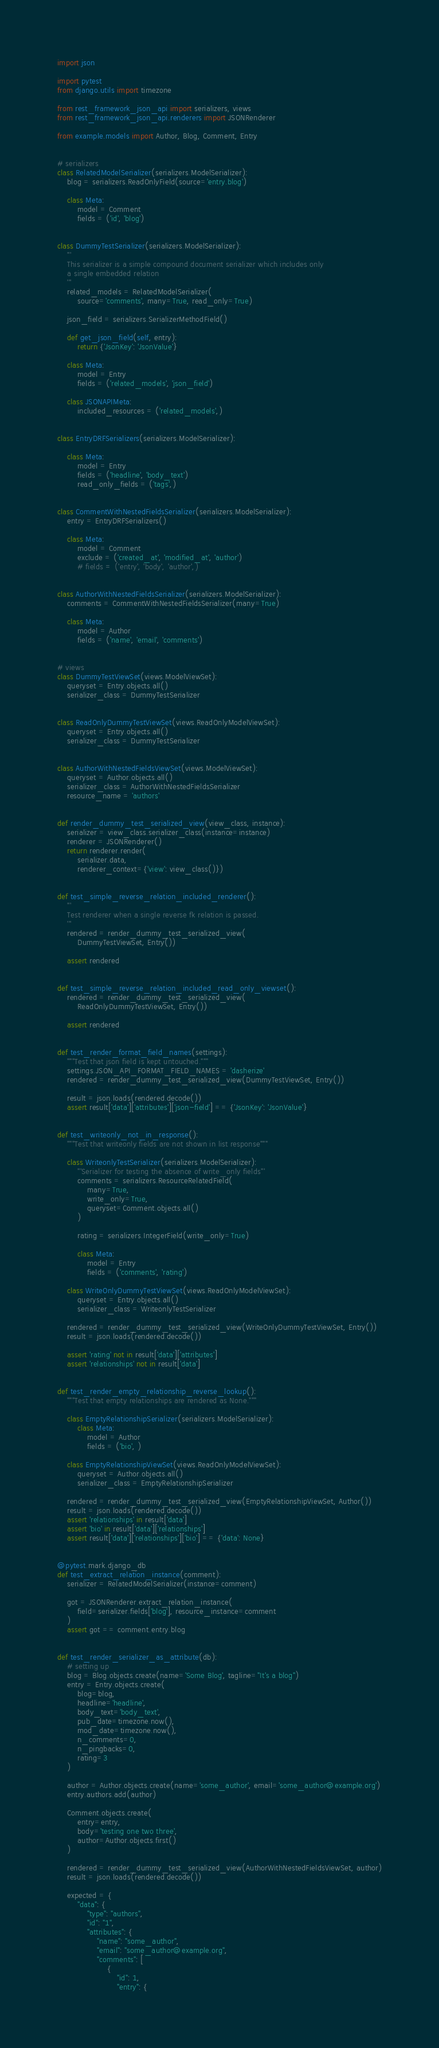<code> <loc_0><loc_0><loc_500><loc_500><_Python_>import json

import pytest
from django.utils import timezone

from rest_framework_json_api import serializers, views
from rest_framework_json_api.renderers import JSONRenderer

from example.models import Author, Blog, Comment, Entry


# serializers
class RelatedModelSerializer(serializers.ModelSerializer):
    blog = serializers.ReadOnlyField(source='entry.blog')

    class Meta:
        model = Comment
        fields = ('id', 'blog')


class DummyTestSerializer(serializers.ModelSerializer):
    '''
    This serializer is a simple compound document serializer which includes only
    a single embedded relation
    '''
    related_models = RelatedModelSerializer(
        source='comments', many=True, read_only=True)

    json_field = serializers.SerializerMethodField()

    def get_json_field(self, entry):
        return {'JsonKey': 'JsonValue'}

    class Meta:
        model = Entry
        fields = ('related_models', 'json_field')

    class JSONAPIMeta:
        included_resources = ('related_models',)


class EntryDRFSerializers(serializers.ModelSerializer):

    class Meta:
        model = Entry
        fields = ('headline', 'body_text')
        read_only_fields = ('tags',)


class CommentWithNestedFieldsSerializer(serializers.ModelSerializer):
    entry = EntryDRFSerializers()

    class Meta:
        model = Comment
        exclude = ('created_at', 'modified_at', 'author')
        # fields = ('entry', 'body', 'author',)


class AuthorWithNestedFieldsSerializer(serializers.ModelSerializer):
    comments = CommentWithNestedFieldsSerializer(many=True)

    class Meta:
        model = Author
        fields = ('name', 'email', 'comments')


# views
class DummyTestViewSet(views.ModelViewSet):
    queryset = Entry.objects.all()
    serializer_class = DummyTestSerializer


class ReadOnlyDummyTestViewSet(views.ReadOnlyModelViewSet):
    queryset = Entry.objects.all()
    serializer_class = DummyTestSerializer


class AuthorWithNestedFieldsViewSet(views.ModelViewSet):
    queryset = Author.objects.all()
    serializer_class = AuthorWithNestedFieldsSerializer
    resource_name = 'authors'


def render_dummy_test_serialized_view(view_class, instance):
    serializer = view_class.serializer_class(instance=instance)
    renderer = JSONRenderer()
    return renderer.render(
        serializer.data,
        renderer_context={'view': view_class()})


def test_simple_reverse_relation_included_renderer():
    '''
    Test renderer when a single reverse fk relation is passed.
    '''
    rendered = render_dummy_test_serialized_view(
        DummyTestViewSet, Entry())

    assert rendered


def test_simple_reverse_relation_included_read_only_viewset():
    rendered = render_dummy_test_serialized_view(
        ReadOnlyDummyTestViewSet, Entry())

    assert rendered


def test_render_format_field_names(settings):
    """Test that json field is kept untouched."""
    settings.JSON_API_FORMAT_FIELD_NAMES = 'dasherize'
    rendered = render_dummy_test_serialized_view(DummyTestViewSet, Entry())

    result = json.loads(rendered.decode())
    assert result['data']['attributes']['json-field'] == {'JsonKey': 'JsonValue'}


def test_writeonly_not_in_response():
    """Test that writeonly fields are not shown in list response"""

    class WriteonlyTestSerializer(serializers.ModelSerializer):
        '''Serializer for testing the absence of write_only fields'''
        comments = serializers.ResourceRelatedField(
            many=True,
            write_only=True,
            queryset=Comment.objects.all()
        )

        rating = serializers.IntegerField(write_only=True)

        class Meta:
            model = Entry
            fields = ('comments', 'rating')

    class WriteOnlyDummyTestViewSet(views.ReadOnlyModelViewSet):
        queryset = Entry.objects.all()
        serializer_class = WriteonlyTestSerializer

    rendered = render_dummy_test_serialized_view(WriteOnlyDummyTestViewSet, Entry())
    result = json.loads(rendered.decode())

    assert 'rating' not in result['data']['attributes']
    assert 'relationships' not in result['data']


def test_render_empty_relationship_reverse_lookup():
    """Test that empty relationships are rendered as None."""

    class EmptyRelationshipSerializer(serializers.ModelSerializer):
        class Meta:
            model = Author
            fields = ('bio', )

    class EmptyRelationshipViewSet(views.ReadOnlyModelViewSet):
        queryset = Author.objects.all()
        serializer_class = EmptyRelationshipSerializer

    rendered = render_dummy_test_serialized_view(EmptyRelationshipViewSet, Author())
    result = json.loads(rendered.decode())
    assert 'relationships' in result['data']
    assert 'bio' in result['data']['relationships']
    assert result['data']['relationships']['bio'] == {'data': None}


@pytest.mark.django_db
def test_extract_relation_instance(comment):
    serializer = RelatedModelSerializer(instance=comment)

    got = JSONRenderer.extract_relation_instance(
        field=serializer.fields['blog'], resource_instance=comment
    )
    assert got == comment.entry.blog


def test_render_serializer_as_attribute(db):
    # setting up
    blog = Blog.objects.create(name='Some Blog', tagline="It's a blog")
    entry = Entry.objects.create(
        blog=blog,
        headline='headline',
        body_text='body_text',
        pub_date=timezone.now(),
        mod_date=timezone.now(),
        n_comments=0,
        n_pingbacks=0,
        rating=3
    )

    author = Author.objects.create(name='some_author', email='some_author@example.org')
    entry.authors.add(author)

    Comment.objects.create(
        entry=entry,
        body='testing one two three',
        author=Author.objects.first()
    )

    rendered = render_dummy_test_serialized_view(AuthorWithNestedFieldsViewSet, author)
    result = json.loads(rendered.decode())

    expected = {
        "data": {
            "type": "authors",
            "id": "1",
            "attributes": {
                "name": "some_author",
                "email": "some_author@example.org",
                "comments": [
                    {
                        "id": 1,
                        "entry": {</code> 